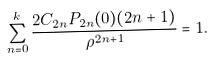<formula> <loc_0><loc_0><loc_500><loc_500>\sum _ { n = 0 } ^ { k } \frac { 2 C _ { 2 n } P _ { 2 n } ( 0 ) ( 2 n + 1 ) } { \rho ^ { 2 n + 1 } } = 1 .</formula> 